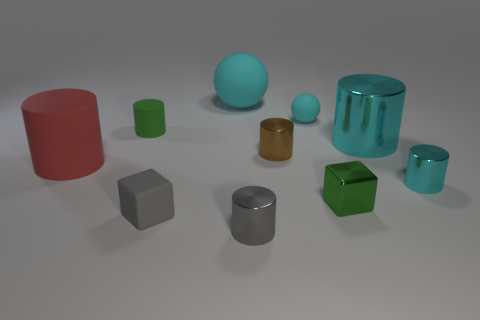Subtract 2 balls. How many balls are left? 0 Subtract all green cubes. How many cubes are left? 1 Subtract all green matte cylinders. How many cylinders are left? 5 Subtract all tiny cylinders. Subtract all cyan rubber things. How many objects are left? 4 Add 1 red objects. How many red objects are left? 2 Add 5 purple rubber cylinders. How many purple rubber cylinders exist? 5 Subtract 0 yellow cubes. How many objects are left? 10 Subtract all balls. How many objects are left? 8 Subtract all brown cylinders. Subtract all red blocks. How many cylinders are left? 5 Subtract all brown spheres. How many red cylinders are left? 1 